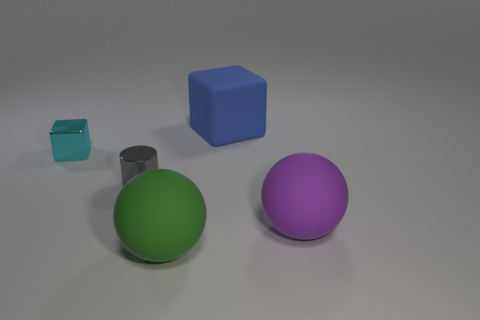The big rubber thing that is in front of the big purple rubber thing is what color?
Keep it short and to the point. Green. Are there more tiny cyan cubes on the right side of the large blue matte cube than large brown matte spheres?
Provide a succinct answer. No. What color is the shiny block?
Provide a short and direct response. Cyan. There is a cyan metal thing that is to the left of the rubber ball left of the large rubber object that is behind the big purple ball; what shape is it?
Offer a terse response. Cube. There is a thing that is both behind the gray shiny thing and on the left side of the large blue rubber thing; what material is it?
Your answer should be very brief. Metal. The large matte thing left of the large matte thing that is behind the metallic cylinder is what shape?
Provide a short and direct response. Sphere. Is there any other thing that has the same color as the cylinder?
Your answer should be compact. No. Is the size of the green matte thing the same as the shiny thing behind the gray cylinder?
Offer a terse response. No. How many large objects are blocks or brown things?
Offer a terse response. 1. Is the number of tiny cyan blocks greater than the number of small things?
Provide a succinct answer. No. 